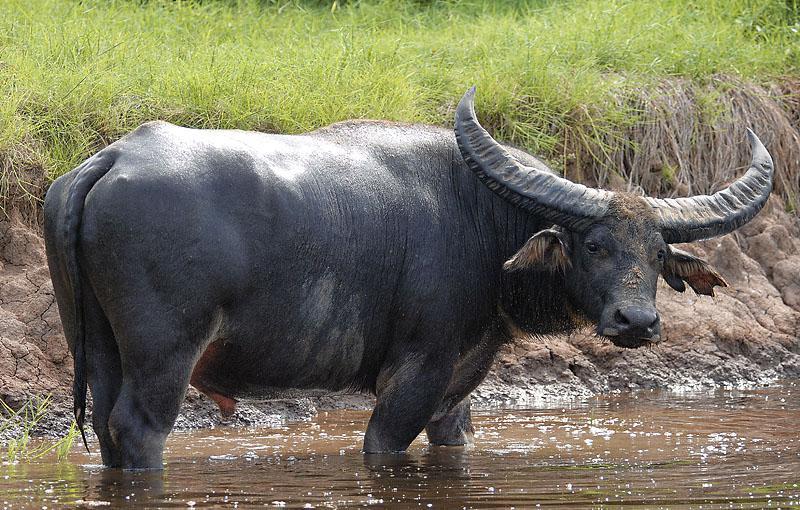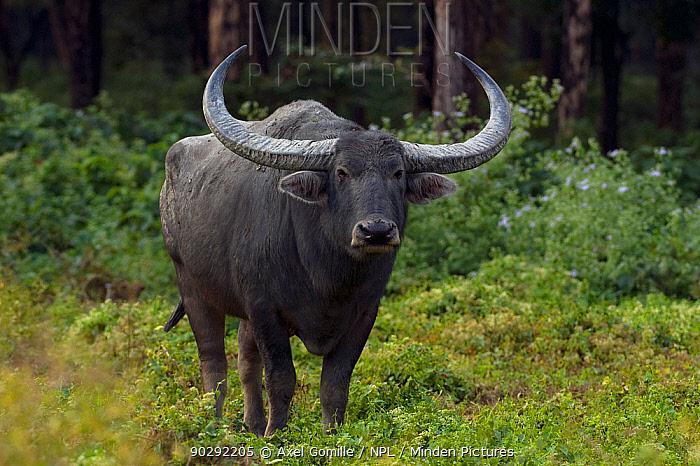The first image is the image on the left, the second image is the image on the right. Analyze the images presented: Is the assertion "The right image contains no more than one water buffalo." valid? Answer yes or no. Yes. The first image is the image on the left, the second image is the image on the right. For the images displayed, is the sentence "The righthand image shows exactly one water buffalo, which faces the camera." factually correct? Answer yes or no. Yes. The first image is the image on the left, the second image is the image on the right. For the images displayed, is the sentence "Each image contains just one water buffalo." factually correct? Answer yes or no. Yes. The first image is the image on the left, the second image is the image on the right. Analyze the images presented: Is the assertion "At least one ox is standing in the water." valid? Answer yes or no. Yes. 